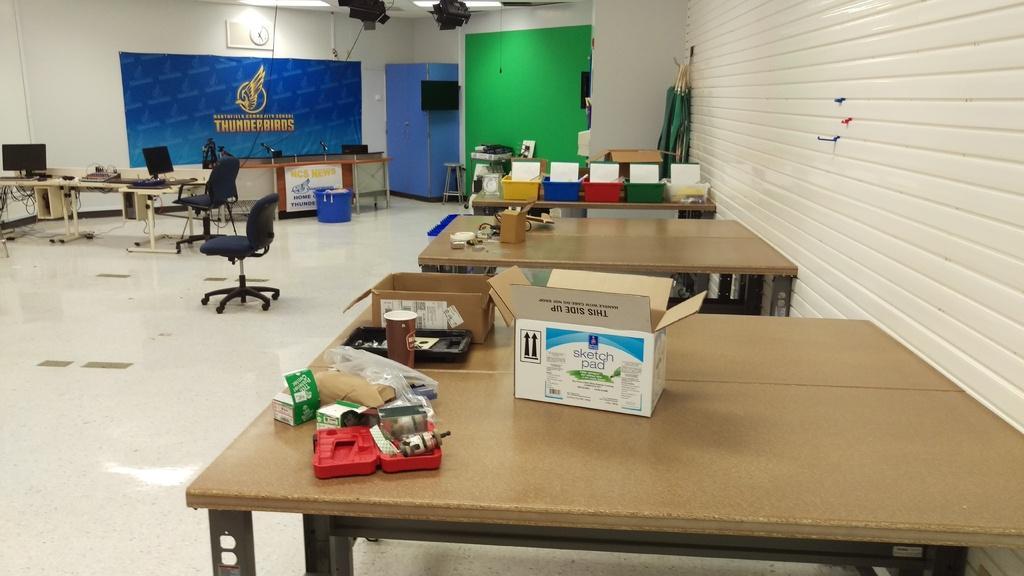In one or two sentences, can you explain what this image depicts? In this picture there are tables at the right side of the image which contains different boxes and trays on it, there is a clock on the wall at the left side of the image and a focusing light above the area of the image, there are two computers and chairs at the left side of the image. 